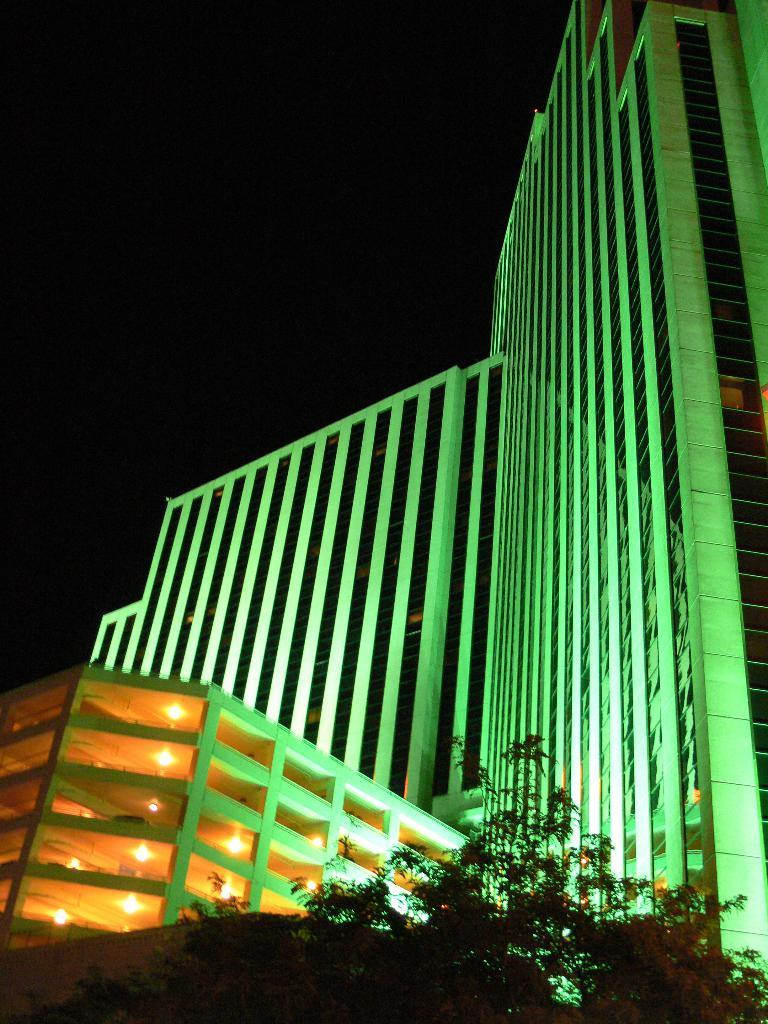What type of structure is illuminated in the image? There is a building with lights in the image. What natural elements are present at the bottom of the image? There are trees at the bottom of the image. What can be seen in the distance in the image? The sky is visible in the background of the image. What is the rate at which the banana is growing in the image? There is no banana present in the image, so it is not possible to determine its growth rate. 